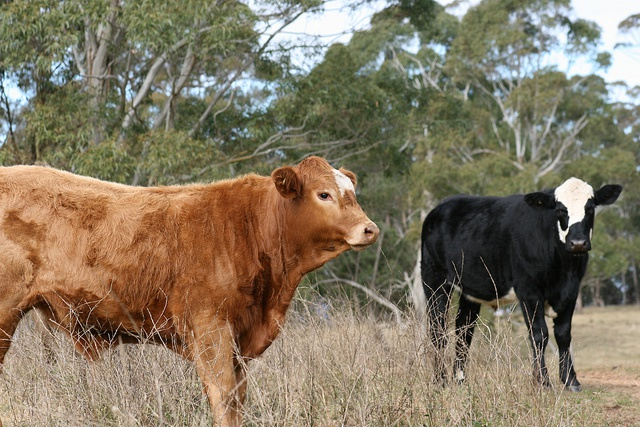Describe the objects in this image and their specific colors. I can see cow in darkgreen, brown, maroon, tan, and salmon tones and cow in darkgreen, black, gray, darkgray, and ivory tones in this image. 